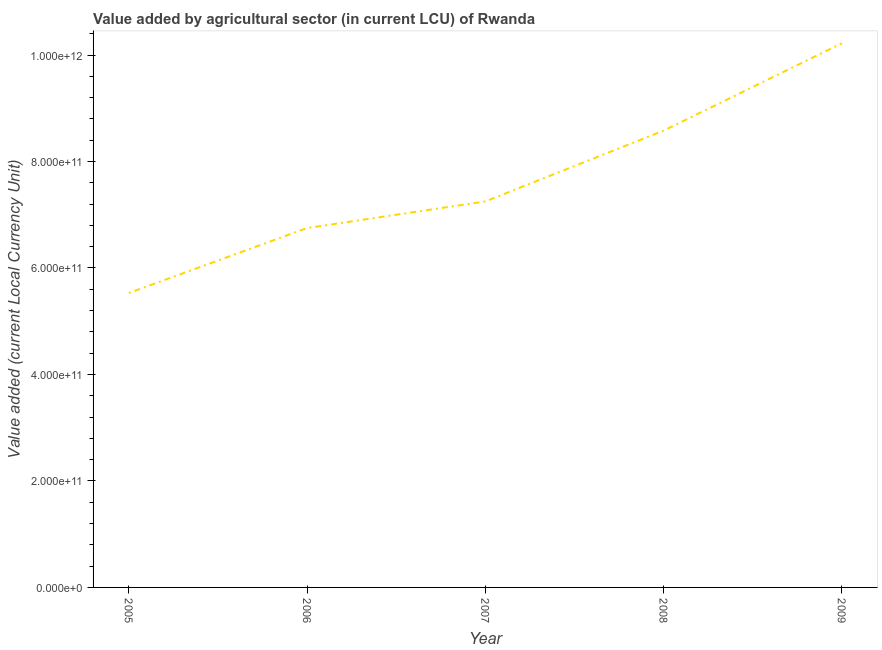What is the value added by agriculture sector in 2009?
Your response must be concise. 1.02e+12. Across all years, what is the maximum value added by agriculture sector?
Make the answer very short. 1.02e+12. Across all years, what is the minimum value added by agriculture sector?
Ensure brevity in your answer.  5.53e+11. What is the sum of the value added by agriculture sector?
Offer a very short reply. 3.83e+12. What is the difference between the value added by agriculture sector in 2006 and 2009?
Keep it short and to the point. -3.47e+11. What is the average value added by agriculture sector per year?
Your answer should be compact. 7.67e+11. What is the median value added by agriculture sector?
Your answer should be very brief. 7.25e+11. In how many years, is the value added by agriculture sector greater than 360000000000 LCU?
Offer a very short reply. 5. What is the ratio of the value added by agriculture sector in 2005 to that in 2006?
Offer a very short reply. 0.82. Is the value added by agriculture sector in 2006 less than that in 2009?
Keep it short and to the point. Yes. What is the difference between the highest and the second highest value added by agriculture sector?
Keep it short and to the point. 1.64e+11. Is the sum of the value added by agriculture sector in 2005 and 2007 greater than the maximum value added by agriculture sector across all years?
Offer a terse response. Yes. What is the difference between the highest and the lowest value added by agriculture sector?
Provide a short and direct response. 4.69e+11. How many lines are there?
Your response must be concise. 1. How many years are there in the graph?
Offer a terse response. 5. What is the difference between two consecutive major ticks on the Y-axis?
Give a very brief answer. 2.00e+11. Are the values on the major ticks of Y-axis written in scientific E-notation?
Provide a succinct answer. Yes. What is the title of the graph?
Give a very brief answer. Value added by agricultural sector (in current LCU) of Rwanda. What is the label or title of the Y-axis?
Provide a short and direct response. Value added (current Local Currency Unit). What is the Value added (current Local Currency Unit) in 2005?
Offer a terse response. 5.53e+11. What is the Value added (current Local Currency Unit) of 2006?
Your response must be concise. 6.75e+11. What is the Value added (current Local Currency Unit) of 2007?
Keep it short and to the point. 7.25e+11. What is the Value added (current Local Currency Unit) of 2008?
Make the answer very short. 8.58e+11. What is the Value added (current Local Currency Unit) of 2009?
Make the answer very short. 1.02e+12. What is the difference between the Value added (current Local Currency Unit) in 2005 and 2006?
Your response must be concise. -1.22e+11. What is the difference between the Value added (current Local Currency Unit) in 2005 and 2007?
Make the answer very short. -1.72e+11. What is the difference between the Value added (current Local Currency Unit) in 2005 and 2008?
Keep it short and to the point. -3.05e+11. What is the difference between the Value added (current Local Currency Unit) in 2005 and 2009?
Provide a short and direct response. -4.69e+11. What is the difference between the Value added (current Local Currency Unit) in 2006 and 2007?
Offer a terse response. -5.00e+1. What is the difference between the Value added (current Local Currency Unit) in 2006 and 2008?
Your response must be concise. -1.83e+11. What is the difference between the Value added (current Local Currency Unit) in 2006 and 2009?
Your answer should be very brief. -3.47e+11. What is the difference between the Value added (current Local Currency Unit) in 2007 and 2008?
Provide a succinct answer. -1.33e+11. What is the difference between the Value added (current Local Currency Unit) in 2007 and 2009?
Keep it short and to the point. -2.97e+11. What is the difference between the Value added (current Local Currency Unit) in 2008 and 2009?
Make the answer very short. -1.64e+11. What is the ratio of the Value added (current Local Currency Unit) in 2005 to that in 2006?
Offer a terse response. 0.82. What is the ratio of the Value added (current Local Currency Unit) in 2005 to that in 2007?
Give a very brief answer. 0.76. What is the ratio of the Value added (current Local Currency Unit) in 2005 to that in 2008?
Provide a succinct answer. 0.65. What is the ratio of the Value added (current Local Currency Unit) in 2005 to that in 2009?
Keep it short and to the point. 0.54. What is the ratio of the Value added (current Local Currency Unit) in 2006 to that in 2007?
Make the answer very short. 0.93. What is the ratio of the Value added (current Local Currency Unit) in 2006 to that in 2008?
Your response must be concise. 0.79. What is the ratio of the Value added (current Local Currency Unit) in 2006 to that in 2009?
Your answer should be compact. 0.66. What is the ratio of the Value added (current Local Currency Unit) in 2007 to that in 2008?
Give a very brief answer. 0.84. What is the ratio of the Value added (current Local Currency Unit) in 2007 to that in 2009?
Your answer should be very brief. 0.71. What is the ratio of the Value added (current Local Currency Unit) in 2008 to that in 2009?
Provide a succinct answer. 0.84. 